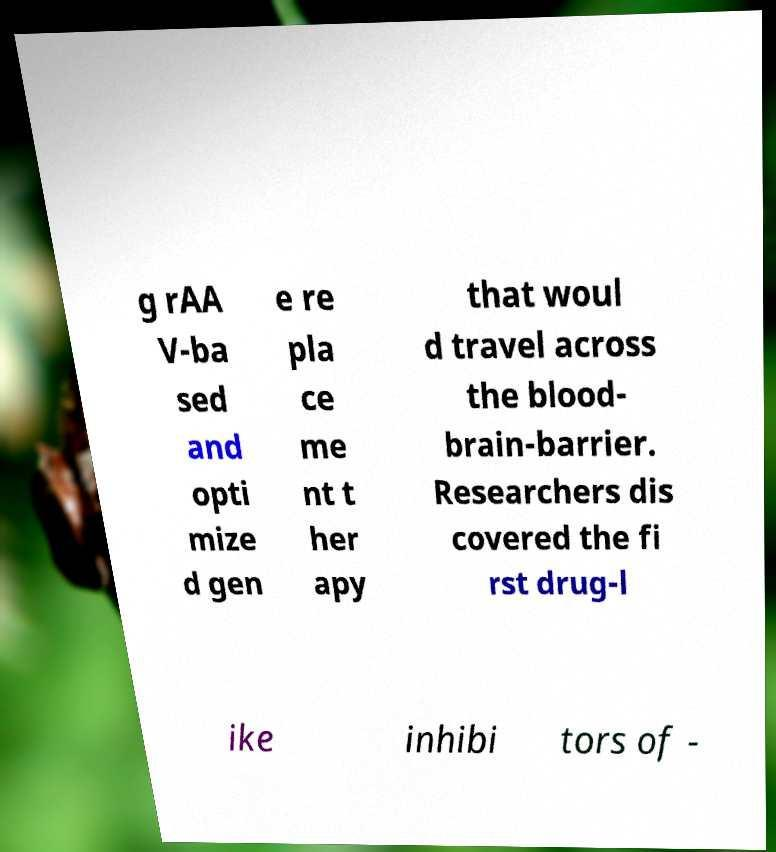There's text embedded in this image that I need extracted. Can you transcribe it verbatim? g rAA V-ba sed and opti mize d gen e re pla ce me nt t her apy that woul d travel across the blood- brain-barrier. Researchers dis covered the fi rst drug-l ike inhibi tors of - 